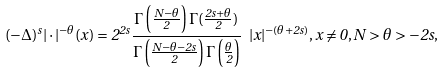Convert formula to latex. <formula><loc_0><loc_0><loc_500><loc_500>( - \Delta ) ^ { s } | \cdot | ^ { - \theta } ( x ) = 2 ^ { 2 s } \frac { \Gamma \left ( \frac { N - \theta } { 2 } \right ) \Gamma ( \frac { 2 s + \theta } { 2 } ) } { \Gamma \left ( \frac { N - \theta - 2 s } { 2 } \right ) \Gamma \left ( \frac { \theta } { 2 } \right ) } \ | x | ^ { - ( \theta + 2 s ) } , x \neq 0 , N > \theta > - 2 s ,</formula> 